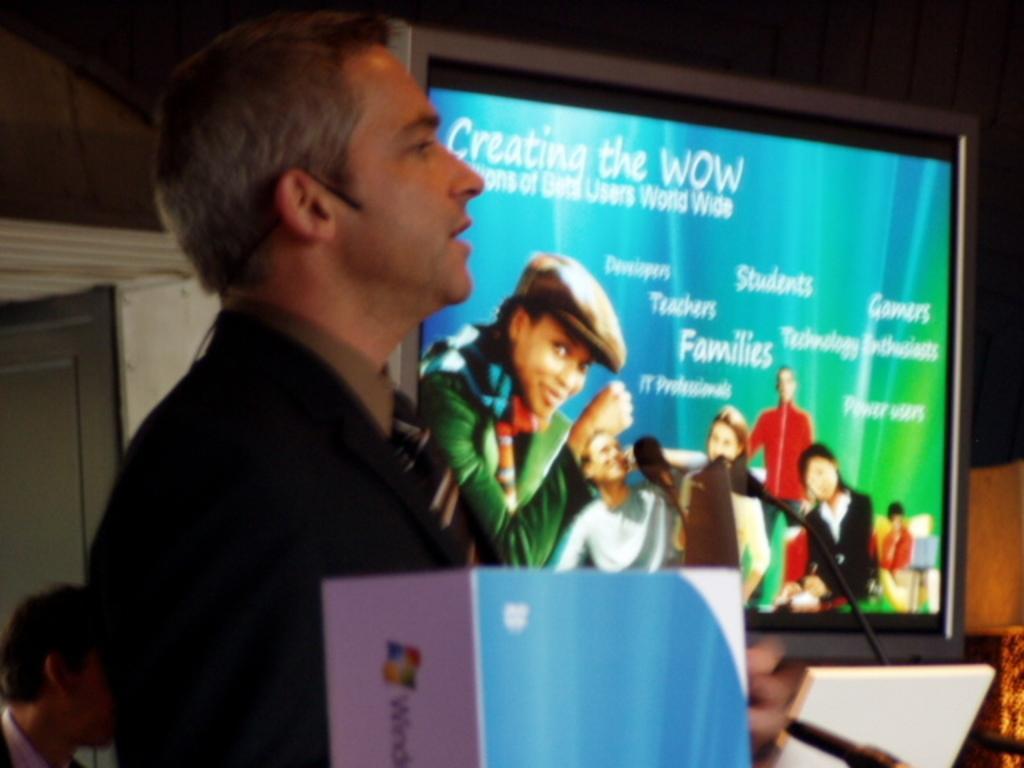Please provide a concise description of this image. In this picture I can observe a man on the left side. In the middle of the picture I can observe large television. In the television screen I can observe some people. 